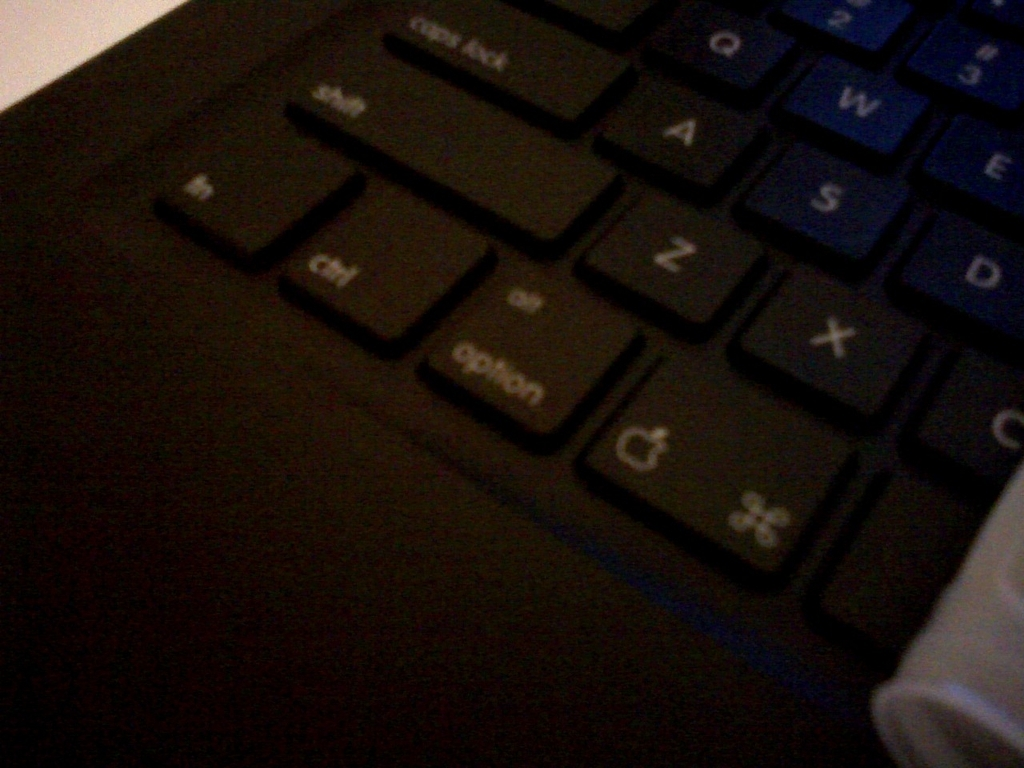Does the image have vibrant colors? The image has a muted color palette, predominantly featuring the dark tones of the keyboard keys with subtle blue backlighting. Although the lighting provides a hint of vibrancy, overall, the colors in the image are not what would typically be described as vibrant. 